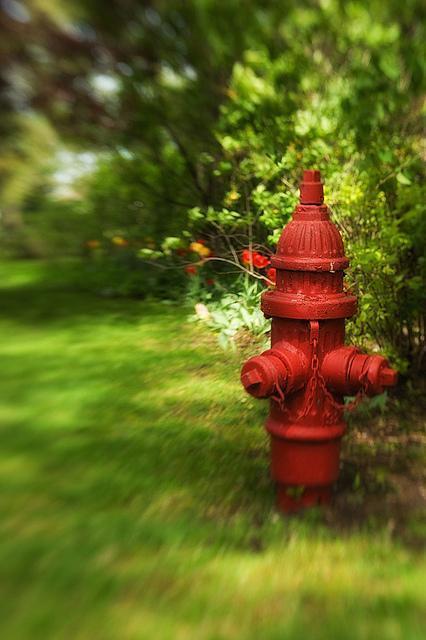How many plugs does the hydrant have?
Give a very brief answer. 2. How many people are there?
Give a very brief answer. 0. 